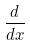Convert formula to latex. <formula><loc_0><loc_0><loc_500><loc_500>\frac { d } { d x }</formula> 